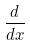Convert formula to latex. <formula><loc_0><loc_0><loc_500><loc_500>\frac { d } { d x }</formula> 